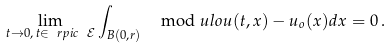<formula> <loc_0><loc_0><loc_500><loc_500>\lim _ { t \to 0 , \, t \in \ r p i c \ \mathcal { E } } \int _ { B ( 0 , r ) } \mod u l o { u ( t , x ) - u _ { o } ( x ) } d x = 0 \, .</formula> 